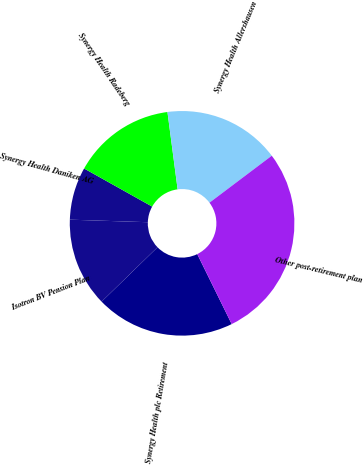<chart> <loc_0><loc_0><loc_500><loc_500><pie_chart><fcel>Synergy Health plc Retirement<fcel>Isotron BV Pension Plan<fcel>Synergy Health Daniken AG<fcel>Synergy Health Radeberg<fcel>Synergy Health Allershausen<fcel>Other post-retirement plan<nl><fcel>20.0%<fcel>12.8%<fcel>7.6%<fcel>14.8%<fcel>16.8%<fcel>28.0%<nl></chart> 